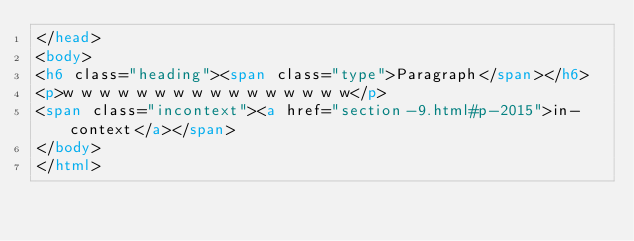Convert code to text. <code><loc_0><loc_0><loc_500><loc_500><_HTML_></head>
<body>
<h6 class="heading"><span class="type">Paragraph</span></h6>
<p>w w w w w w w w w w w w w w w w</p>
<span class="incontext"><a href="section-9.html#p-2015">in-context</a></span>
</body>
</html>
</code> 